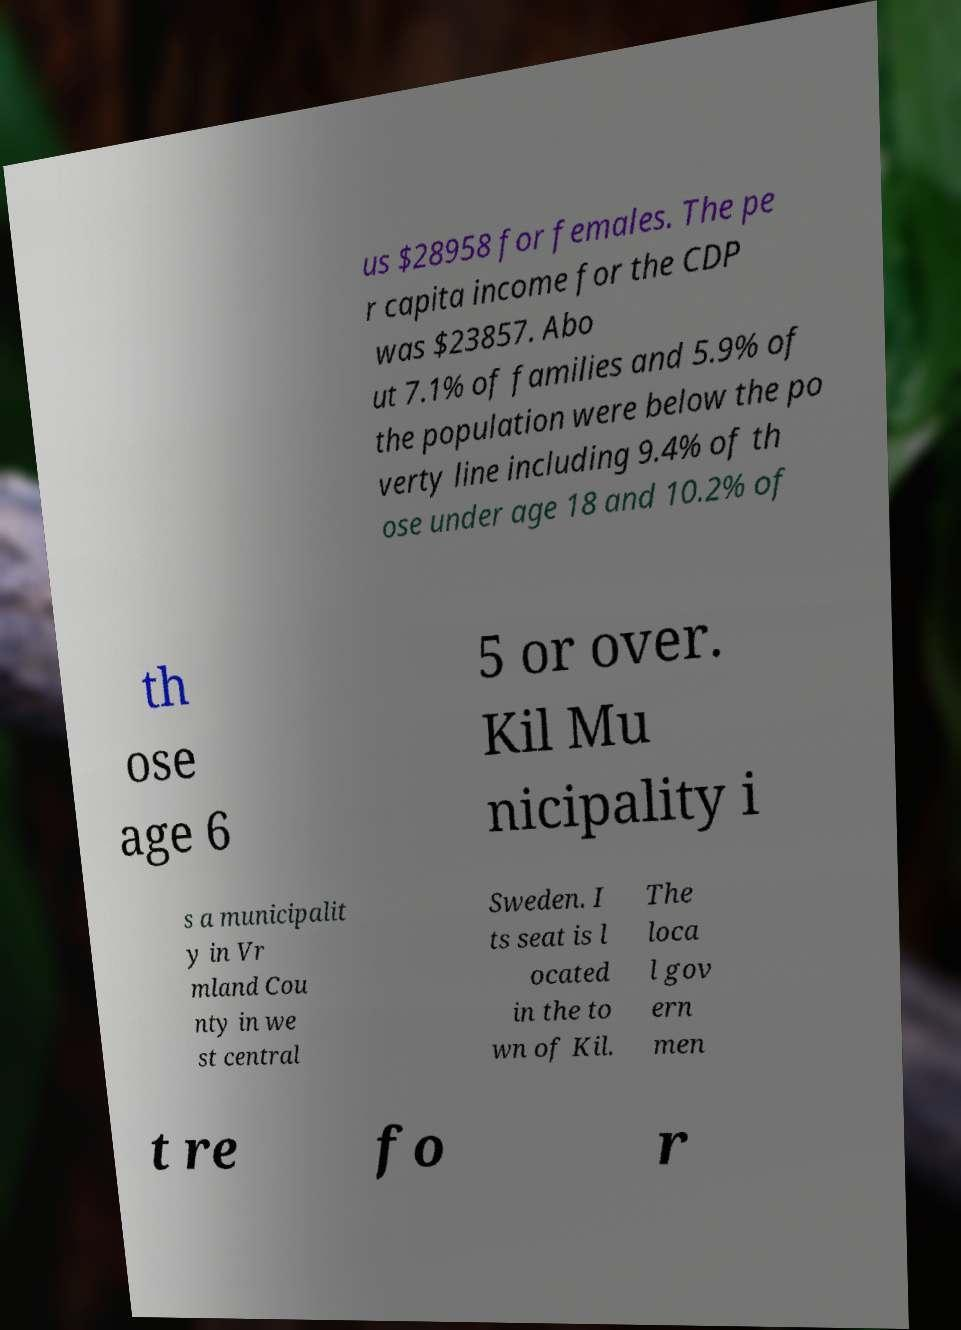Can you read and provide the text displayed in the image?This photo seems to have some interesting text. Can you extract and type it out for me? us $28958 for females. The pe r capita income for the CDP was $23857. Abo ut 7.1% of families and 5.9% of the population were below the po verty line including 9.4% of th ose under age 18 and 10.2% of th ose age 6 5 or over. Kil Mu nicipality i s a municipalit y in Vr mland Cou nty in we st central Sweden. I ts seat is l ocated in the to wn of Kil. The loca l gov ern men t re fo r 